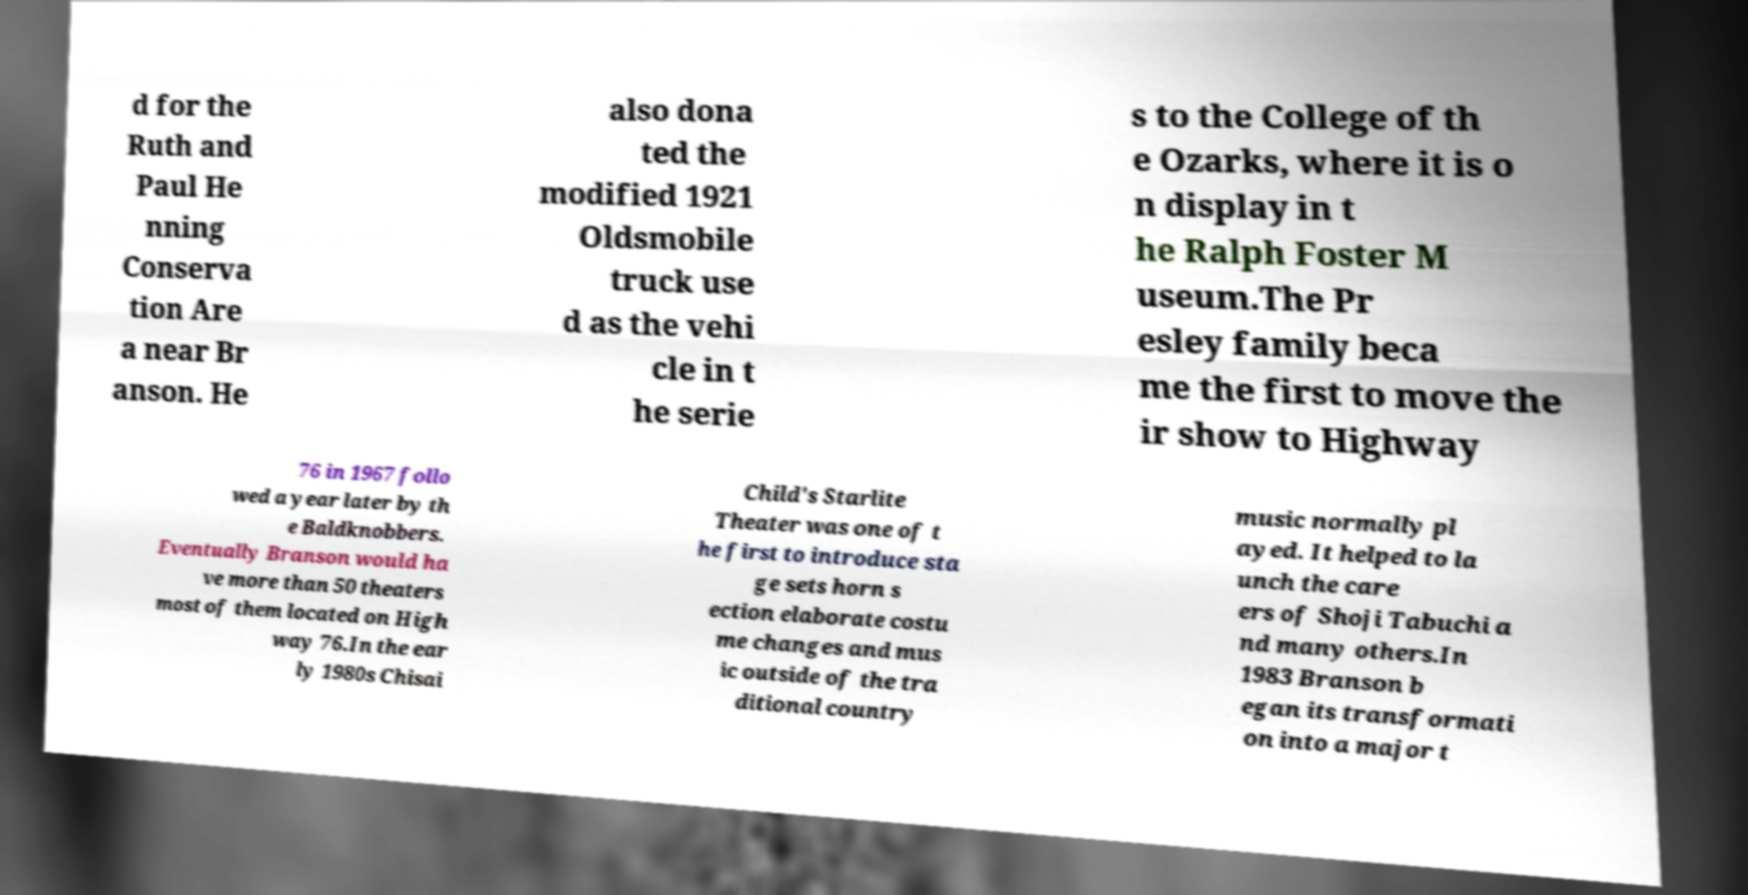For documentation purposes, I need the text within this image transcribed. Could you provide that? d for the Ruth and Paul He nning Conserva tion Are a near Br anson. He also dona ted the modified 1921 Oldsmobile truck use d as the vehi cle in t he serie s to the College of th e Ozarks, where it is o n display in t he Ralph Foster M useum.The Pr esley family beca me the first to move the ir show to Highway 76 in 1967 follo wed a year later by th e Baldknobbers. Eventually Branson would ha ve more than 50 theaters most of them located on High way 76.In the ear ly 1980s Chisai Child's Starlite Theater was one of t he first to introduce sta ge sets horn s ection elaborate costu me changes and mus ic outside of the tra ditional country music normally pl ayed. It helped to la unch the care ers of Shoji Tabuchi a nd many others.In 1983 Branson b egan its transformati on into a major t 